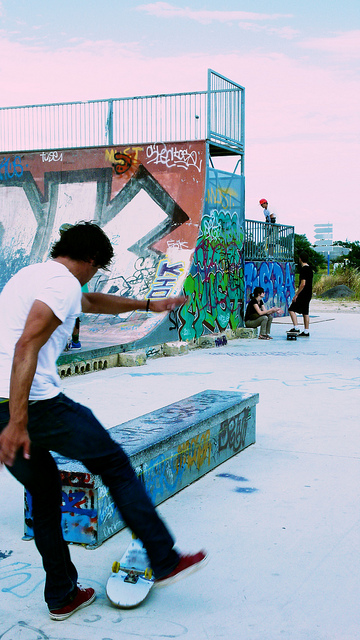What time of day does it appear to be in this photo? Judging by the lighting and shadows in the photo, it seems to be taken in the late afternoon. The sky has a soft, warm glow, which suggests that the sun is setting, casting elongated shadows and bathing the skatepark in a golden light often associated with the 'golden hour,' a period shortly after sunrise or before sunset. 